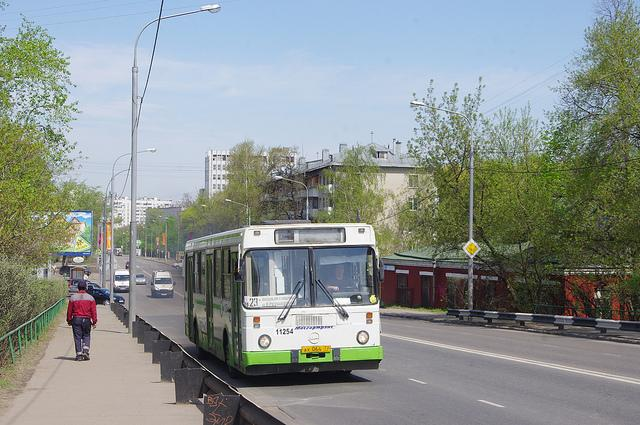Which car is in the greatest danger? Please explain your reasoning. black car. The car that's black is in danger. 